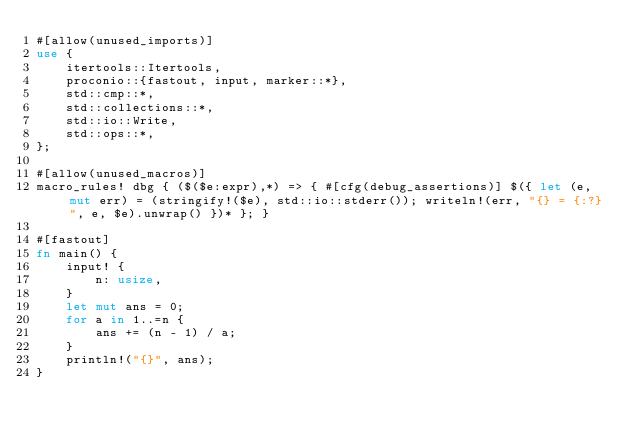Convert code to text. <code><loc_0><loc_0><loc_500><loc_500><_Rust_>#[allow(unused_imports)]
use {
    itertools::Itertools,
    proconio::{fastout, input, marker::*},
    std::cmp::*,
    std::collections::*,
    std::io::Write,
    std::ops::*,
};

#[allow(unused_macros)]
macro_rules! dbg { ($($e:expr),*) => { #[cfg(debug_assertions)] $({ let (e, mut err) = (stringify!($e), std::io::stderr()); writeln!(err, "{} = {:?}", e, $e).unwrap() })* }; }

#[fastout]
fn main() {
    input! {
        n: usize,
    }
    let mut ans = 0;
    for a in 1..=n {
        ans += (n - 1) / a;
    }
    println!("{}", ans);
}
</code> 